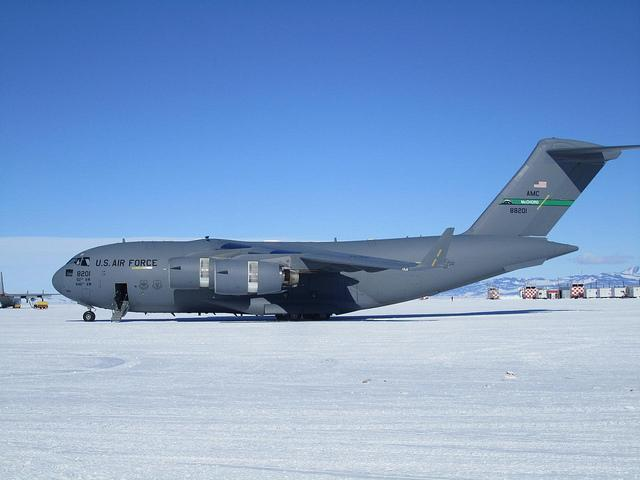The plane is most likely dropping off what to the people?

Choices:
A) weaponized vehicles
B) money
C) furniture
D) supplies supplies 